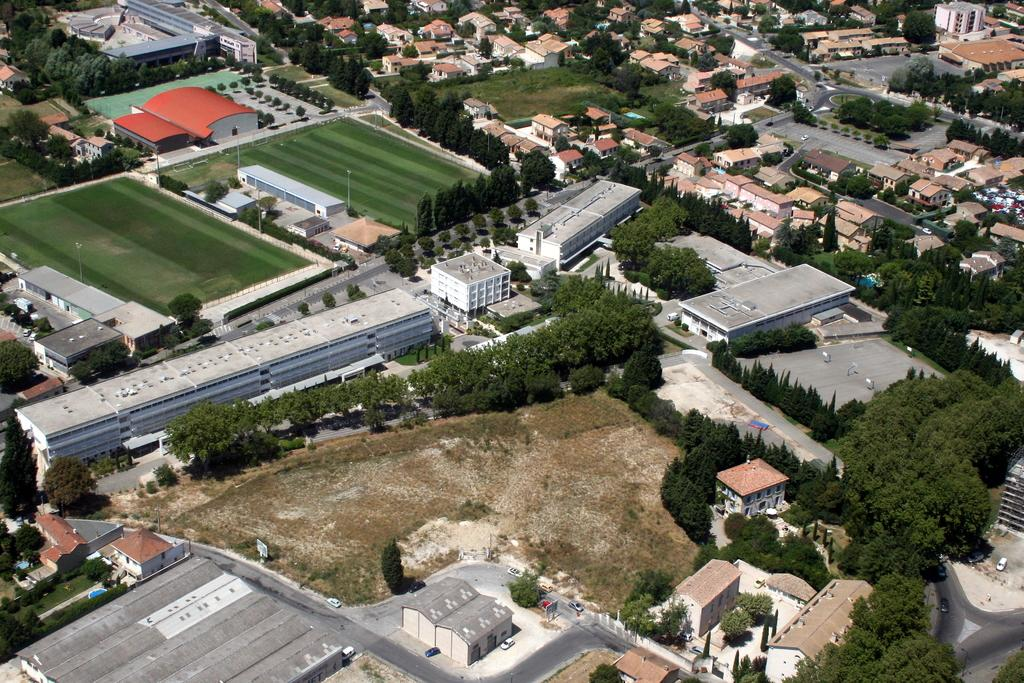What type of view is shown in the image? The image is an aerial view of a city. What can be seen in the image besides the city? There are many homes in the image, and trees surround the homes. What is visible in the background of the image? There are grasslands in the background of the image. How does the quarter feel about the throat in the image? There is no quarter or throat mentioned in the image; it is a view of a city with homes, trees, and grasslands. 